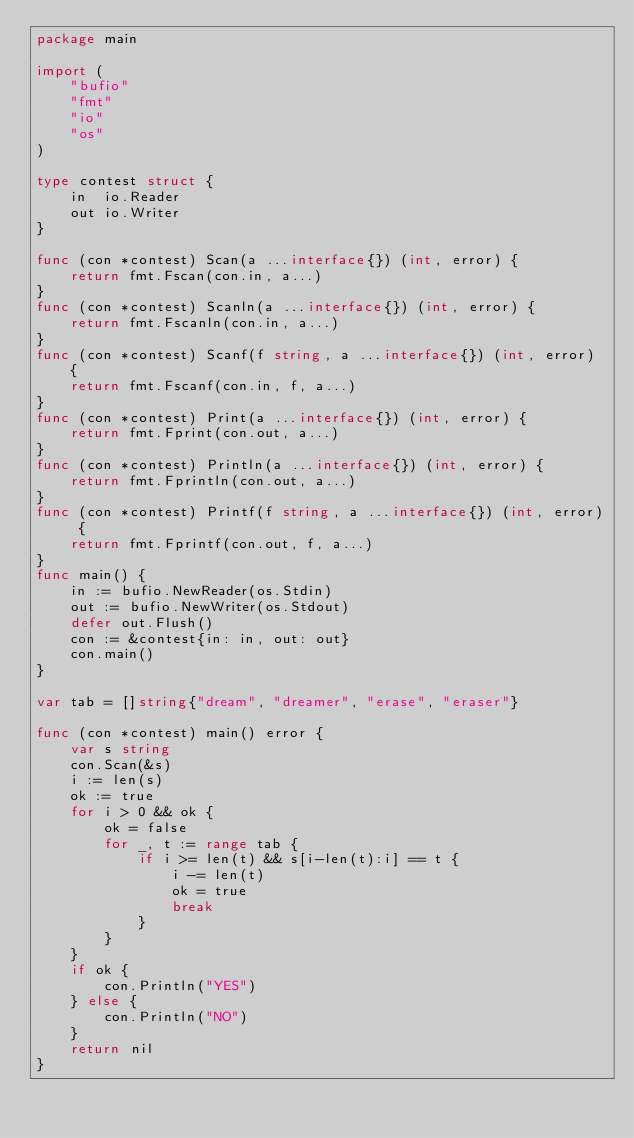<code> <loc_0><loc_0><loc_500><loc_500><_Go_>package main

import (
	"bufio"
	"fmt"
	"io"
	"os"
)

type contest struct {
	in  io.Reader
	out io.Writer
}

func (con *contest) Scan(a ...interface{}) (int, error) {
	return fmt.Fscan(con.in, a...)
}
func (con *contest) Scanln(a ...interface{}) (int, error) {
	return fmt.Fscanln(con.in, a...)
}
func (con *contest) Scanf(f string, a ...interface{}) (int, error) {
	return fmt.Fscanf(con.in, f, a...)
}
func (con *contest) Print(a ...interface{}) (int, error) {
	return fmt.Fprint(con.out, a...)
}
func (con *contest) Println(a ...interface{}) (int, error) {
	return fmt.Fprintln(con.out, a...)
}
func (con *contest) Printf(f string, a ...interface{}) (int, error) {
	return fmt.Fprintf(con.out, f, a...)
}
func main() {
	in := bufio.NewReader(os.Stdin)
	out := bufio.NewWriter(os.Stdout)
	defer out.Flush()
	con := &contest{in: in, out: out}
	con.main()
}

var tab = []string{"dream", "dreamer", "erase", "eraser"}

func (con *contest) main() error {
	var s string
	con.Scan(&s)
	i := len(s)
	ok := true
	for i > 0 && ok {
		ok = false
		for _, t := range tab {
			if i >= len(t) && s[i-len(t):i] == t {
				i -= len(t)
				ok = true
				break
			}
		}
	}
	if ok {
		con.Println("YES")
	} else {
		con.Println("NO")
	}
	return nil
}
</code> 